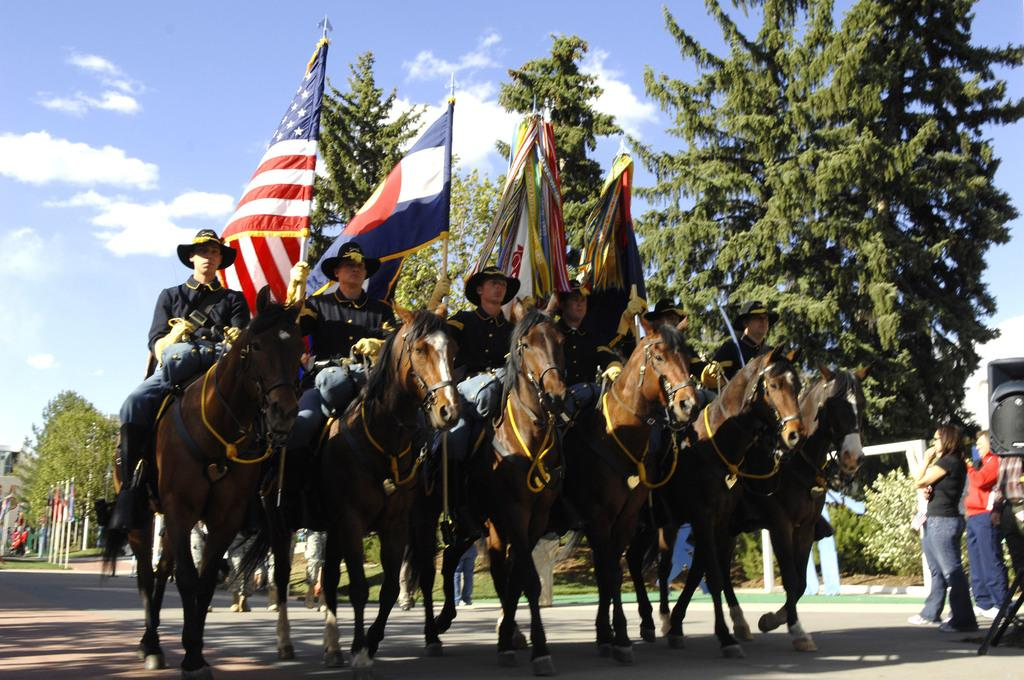What can be seen in the foreground of the picture? In the foreground of the picture, there are people, flags, horses, and a road. What is located in the middle of the picture? In the middle of the picture, there are trees and various objects. What is visible at the top of the picture? Sky is visible at the top of the picture. What type of haircut is the horse getting in the picture? There is no haircut being given to the horse in the picture; it is a photograph of people, flags, horses, and a road in the foreground. Can you tell me how many teeth the tree has in the picture? There are no teeth present in the picture, as it features people, flags, horses, a road, trees, various objects, and sky. 